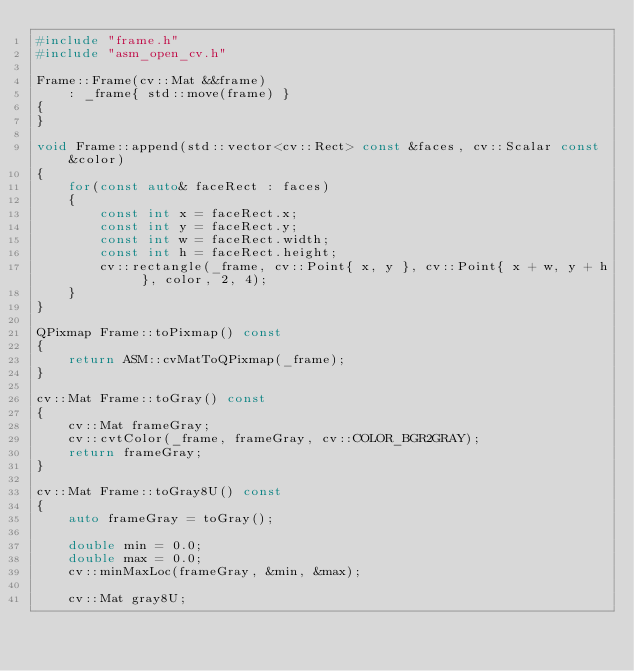<code> <loc_0><loc_0><loc_500><loc_500><_C++_>#include "frame.h"
#include "asm_open_cv.h"

Frame::Frame(cv::Mat &&frame)
    : _frame{ std::move(frame) }
{
}

void Frame::append(std::vector<cv::Rect> const &faces, cv::Scalar const &color)
{
    for(const auto& faceRect : faces)
    {
        const int x = faceRect.x;
        const int y = faceRect.y;
        const int w = faceRect.width;
        const int h = faceRect.height;
        cv::rectangle(_frame, cv::Point{ x, y }, cv::Point{ x + w, y + h }, color, 2, 4);
    }
}

QPixmap Frame::toPixmap() const
{
    return ASM::cvMatToQPixmap(_frame);
}

cv::Mat Frame::toGray() const
{
    cv::Mat frameGray;
    cv::cvtColor(_frame, frameGray, cv::COLOR_BGR2GRAY);
    return frameGray;
}

cv::Mat Frame::toGray8U() const
{
    auto frameGray = toGray();

    double min = 0.0;
    double max = 0.0;
    cv::minMaxLoc(frameGray, &min, &max);

    cv::Mat gray8U;</code> 